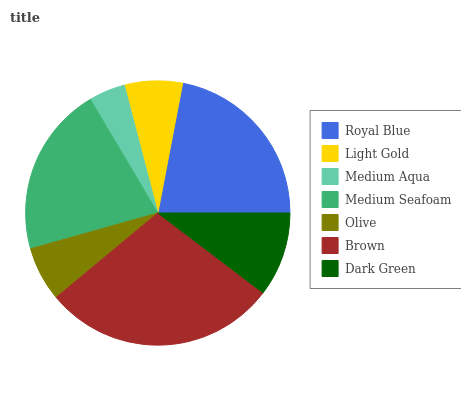Is Medium Aqua the minimum?
Answer yes or no. Yes. Is Brown the maximum?
Answer yes or no. Yes. Is Light Gold the minimum?
Answer yes or no. No. Is Light Gold the maximum?
Answer yes or no. No. Is Royal Blue greater than Light Gold?
Answer yes or no. Yes. Is Light Gold less than Royal Blue?
Answer yes or no. Yes. Is Light Gold greater than Royal Blue?
Answer yes or no. No. Is Royal Blue less than Light Gold?
Answer yes or no. No. Is Dark Green the high median?
Answer yes or no. Yes. Is Dark Green the low median?
Answer yes or no. Yes. Is Olive the high median?
Answer yes or no. No. Is Royal Blue the low median?
Answer yes or no. No. 